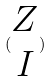Convert formula to latex. <formula><loc_0><loc_0><loc_500><loc_500>( \begin{matrix} Z \\ I \end{matrix} )</formula> 